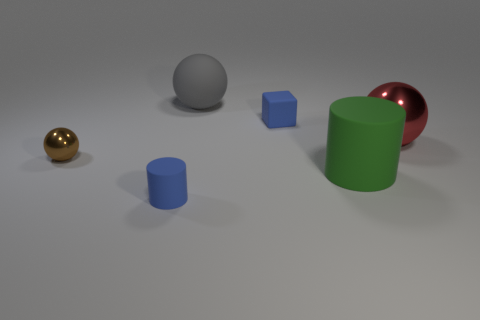Add 1 big gray cubes. How many objects exist? 7 Subtract all small spheres. How many spheres are left? 2 Subtract 1 cylinders. How many cylinders are left? 1 Subtract all blocks. How many objects are left? 5 Subtract all brown balls. How many balls are left? 2 Subtract 0 purple cubes. How many objects are left? 6 Subtract all red cubes. Subtract all green spheres. How many cubes are left? 1 Subtract all green cylinders. How many brown balls are left? 1 Subtract all green balls. Subtract all small metallic spheres. How many objects are left? 5 Add 6 rubber balls. How many rubber balls are left? 7 